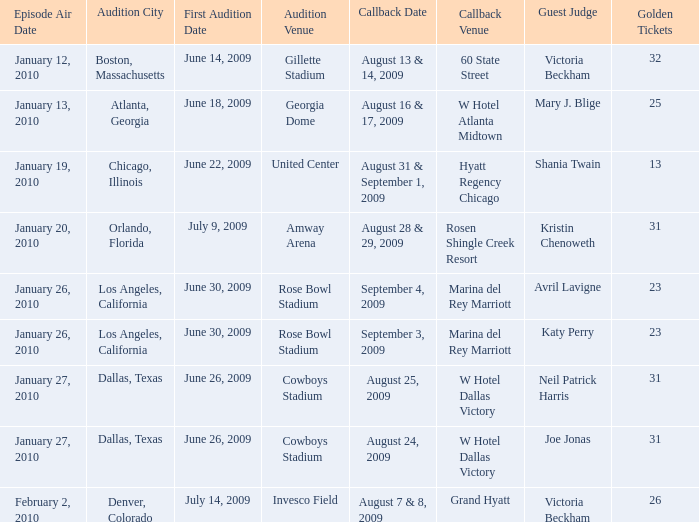Would you be able to parse every entry in this table? {'header': ['Episode Air Date', 'Audition City', 'First Audition Date', 'Audition Venue', 'Callback Date', 'Callback Venue', 'Guest Judge', 'Golden Tickets'], 'rows': [['January 12, 2010', 'Boston, Massachusetts', 'June 14, 2009', 'Gillette Stadium', 'August 13 & 14, 2009', '60 State Street', 'Victoria Beckham', '32'], ['January 13, 2010', 'Atlanta, Georgia', 'June 18, 2009', 'Georgia Dome', 'August 16 & 17, 2009', 'W Hotel Atlanta Midtown', 'Mary J. Blige', '25'], ['January 19, 2010', 'Chicago, Illinois', 'June 22, 2009', 'United Center', 'August 31 & September 1, 2009', 'Hyatt Regency Chicago', 'Shania Twain', '13'], ['January 20, 2010', 'Orlando, Florida', 'July 9, 2009', 'Amway Arena', 'August 28 & 29, 2009', 'Rosen Shingle Creek Resort', 'Kristin Chenoweth', '31'], ['January 26, 2010', 'Los Angeles, California', 'June 30, 2009', 'Rose Bowl Stadium', 'September 4, 2009', 'Marina del Rey Marriott', 'Avril Lavigne', '23'], ['January 26, 2010', 'Los Angeles, California', 'June 30, 2009', 'Rose Bowl Stadium', 'September 3, 2009', 'Marina del Rey Marriott', 'Katy Perry', '23'], ['January 27, 2010', 'Dallas, Texas', 'June 26, 2009', 'Cowboys Stadium', 'August 25, 2009', 'W Hotel Dallas Victory', 'Neil Patrick Harris', '31'], ['January 27, 2010', 'Dallas, Texas', 'June 26, 2009', 'Cowboys Stadium', 'August 24, 2009', 'W Hotel Dallas Victory', 'Joe Jonas', '31'], ['February 2, 2010', 'Denver, Colorado', 'July 14, 2009', 'Invesco Field', 'August 7 & 8, 2009', 'Grand Hyatt', 'Victoria Beckham', '26']]} Can you mention the prestigious golden ticket associated with invesco field? 26.0. 